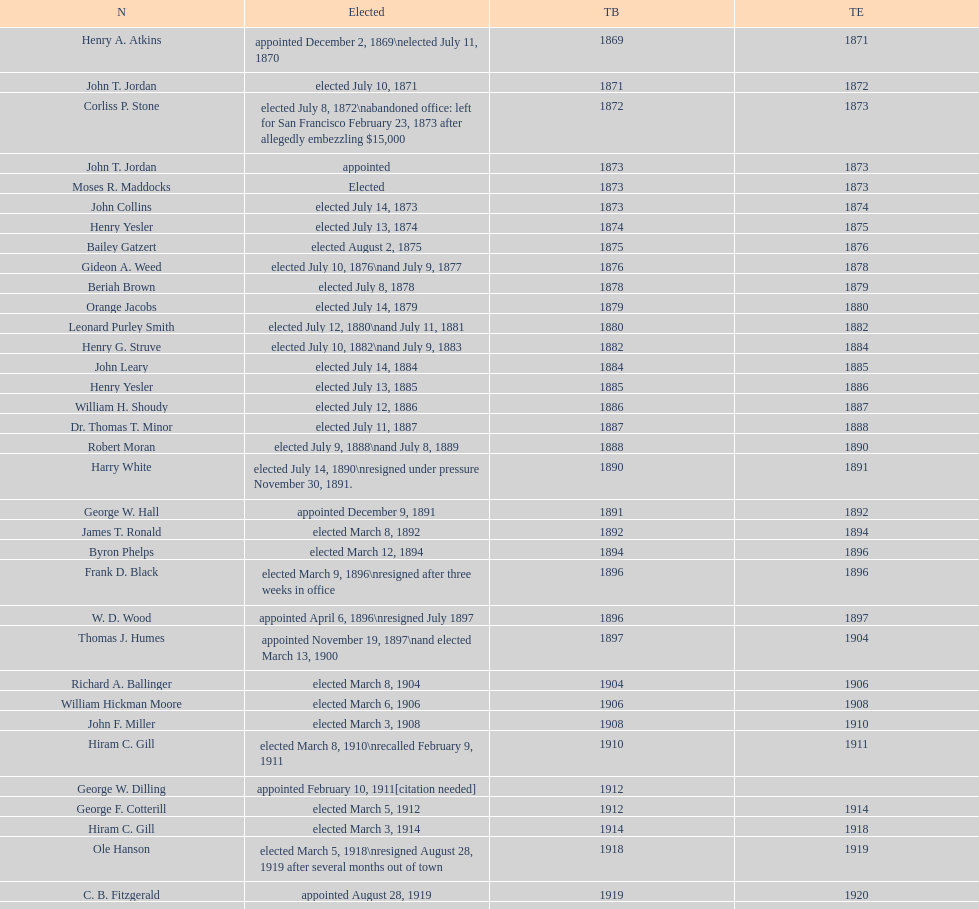What is the count of mayors named john? 6. 